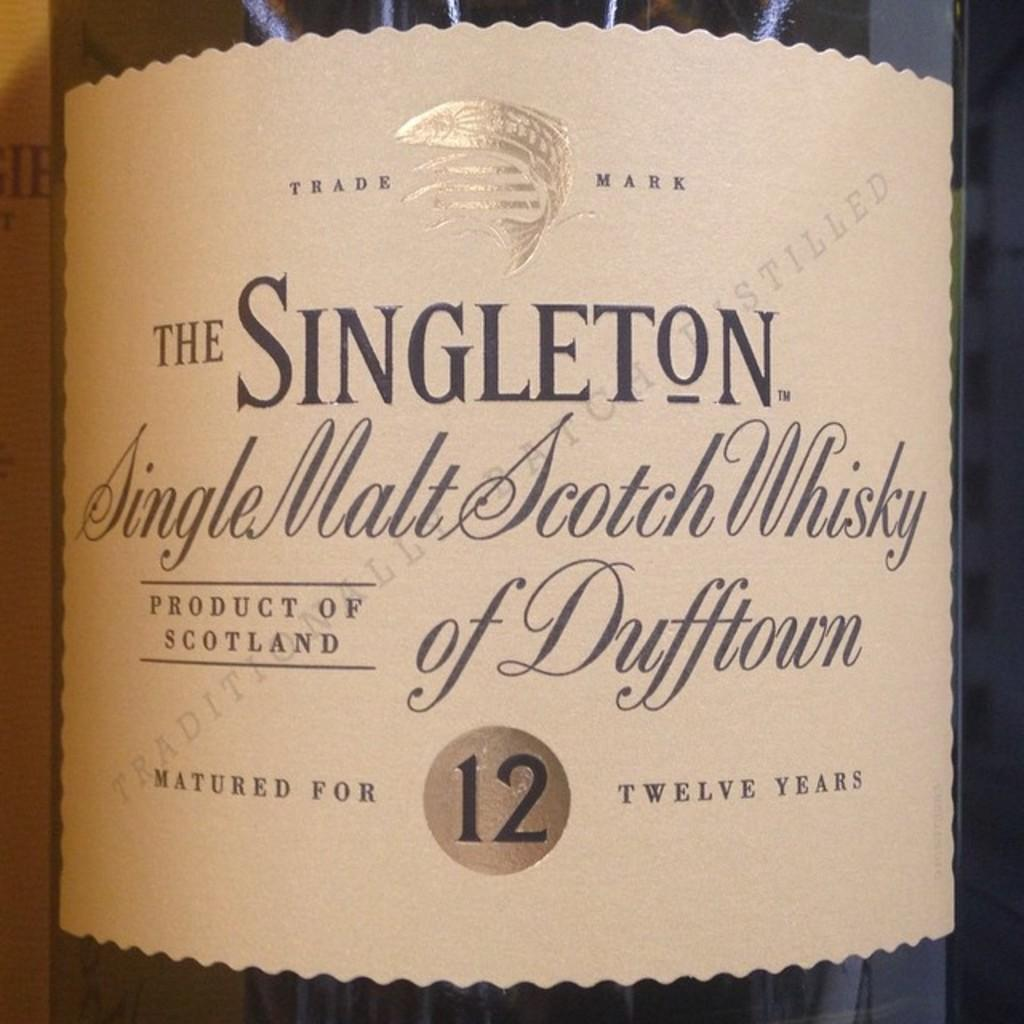<image>
Share a concise interpretation of the image provided. a close up of a wine label for The Singleton 